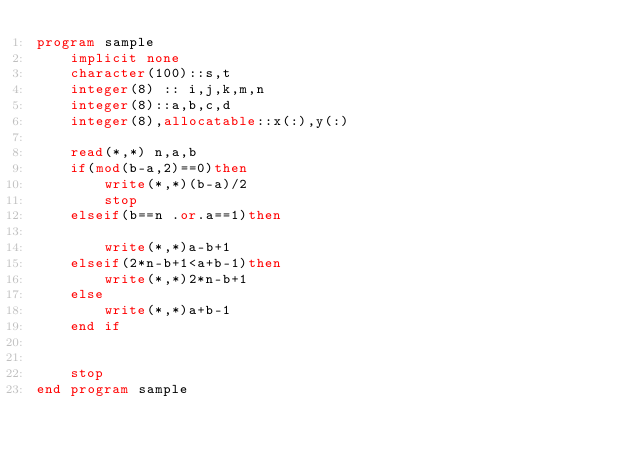<code> <loc_0><loc_0><loc_500><loc_500><_FORTRAN_>program sample
    implicit none
    character(100)::s,t
    integer(8) :: i,j,k,m,n
    integer(8)::a,b,c,d
    integer(8),allocatable::x(:),y(:)
  
    read(*,*) n,a,b
    if(mod(b-a,2)==0)then
        write(*,*)(b-a)/2
        stop
    elseif(b==n .or.a==1)then

        write(*,*)a-b+1
    elseif(2*n-b+1<a+b-1)then
        write(*,*)2*n-b+1
    else
        write(*,*)a+b-1
    end if


    stop
end program sample
  

</code> 